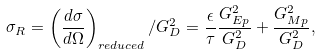Convert formula to latex. <formula><loc_0><loc_0><loc_500><loc_500>\sigma _ { R } = \left ( \frac { d \sigma } { d \Omega } \right ) _ { r e d u c e d } / G _ { D } ^ { 2 } = \frac { \epsilon } { \tau } \frac { G _ { E { p } } ^ { 2 } } { G _ { D } ^ { 2 } } + \frac { G _ { M { p } } ^ { 2 } } { G _ { D } ^ { 2 } } ,</formula> 